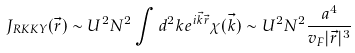Convert formula to latex. <formula><loc_0><loc_0><loc_500><loc_500>J _ { R K K Y } ( { \vec { r } } ) \sim U ^ { 2 } N ^ { 2 } \int d ^ { 2 } { k } e ^ { i { \vec { k } } { \vec { r } } } \chi ( { \vec { k } } ) \sim U ^ { 2 } N ^ { 2 } \frac { a ^ { 4 } } { v _ { F } | { \vec { r } } | ^ { 3 } }</formula> 